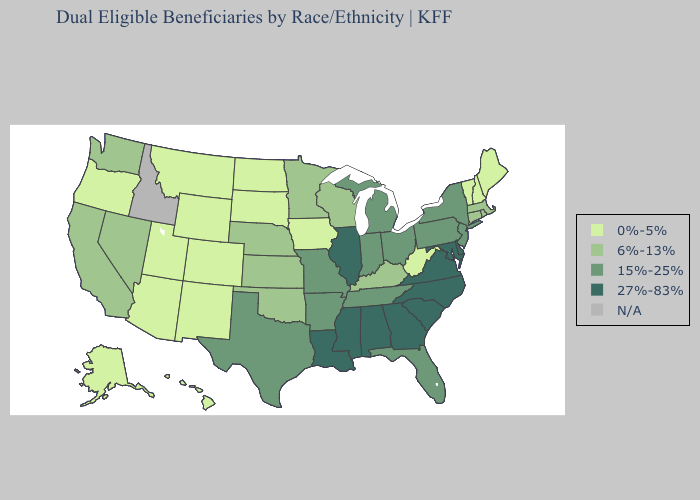Does Washington have the highest value in the USA?
Keep it brief. No. Does Alabama have the highest value in the USA?
Quick response, please. Yes. What is the value of Idaho?
Give a very brief answer. N/A. What is the lowest value in the MidWest?
Concise answer only. 0%-5%. What is the value of North Dakota?
Give a very brief answer. 0%-5%. What is the value of Ohio?
Short answer required. 15%-25%. Name the states that have a value in the range 0%-5%?
Concise answer only. Alaska, Arizona, Colorado, Hawaii, Iowa, Maine, Montana, New Hampshire, New Mexico, North Dakota, Oregon, South Dakota, Utah, Vermont, West Virginia, Wyoming. What is the value of North Dakota?
Short answer required. 0%-5%. Name the states that have a value in the range 6%-13%?
Be succinct. California, Connecticut, Kansas, Kentucky, Massachusetts, Minnesota, Nebraska, Nevada, Oklahoma, Rhode Island, Washington, Wisconsin. Name the states that have a value in the range 6%-13%?
Write a very short answer. California, Connecticut, Kansas, Kentucky, Massachusetts, Minnesota, Nebraska, Nevada, Oklahoma, Rhode Island, Washington, Wisconsin. Does Wyoming have the lowest value in the USA?
Keep it brief. Yes. 